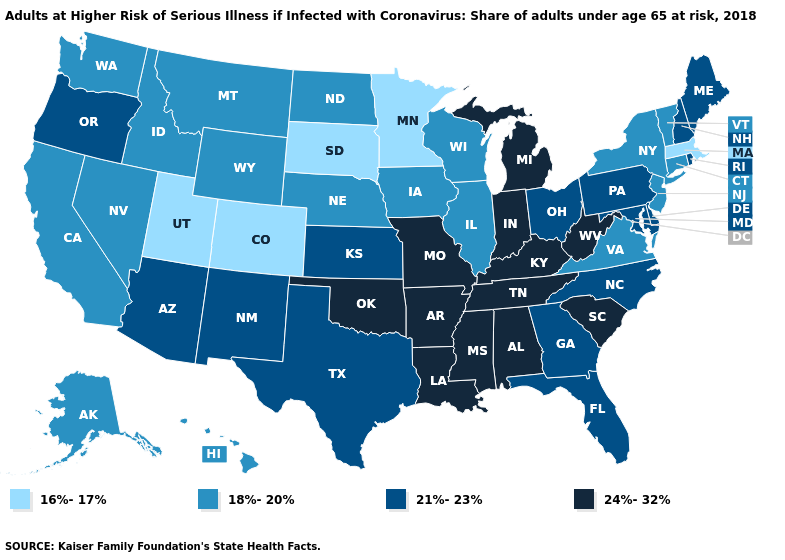Name the states that have a value in the range 24%-32%?
Be succinct. Alabama, Arkansas, Indiana, Kentucky, Louisiana, Michigan, Mississippi, Missouri, Oklahoma, South Carolina, Tennessee, West Virginia. What is the lowest value in states that border Connecticut?
Write a very short answer. 16%-17%. What is the lowest value in the USA?
Concise answer only. 16%-17%. Name the states that have a value in the range 24%-32%?
Quick response, please. Alabama, Arkansas, Indiana, Kentucky, Louisiana, Michigan, Mississippi, Missouri, Oklahoma, South Carolina, Tennessee, West Virginia. What is the value of Wyoming?
Concise answer only. 18%-20%. What is the lowest value in the USA?
Be succinct. 16%-17%. What is the value of Illinois?
Short answer required. 18%-20%. Name the states that have a value in the range 21%-23%?
Write a very short answer. Arizona, Delaware, Florida, Georgia, Kansas, Maine, Maryland, New Hampshire, New Mexico, North Carolina, Ohio, Oregon, Pennsylvania, Rhode Island, Texas. What is the highest value in the USA?
Keep it brief. 24%-32%. Among the states that border Texas , which have the lowest value?
Quick response, please. New Mexico. Name the states that have a value in the range 18%-20%?
Write a very short answer. Alaska, California, Connecticut, Hawaii, Idaho, Illinois, Iowa, Montana, Nebraska, Nevada, New Jersey, New York, North Dakota, Vermont, Virginia, Washington, Wisconsin, Wyoming. What is the value of Texas?
Write a very short answer. 21%-23%. Does Massachusetts have the lowest value in the Northeast?
Be succinct. Yes. Name the states that have a value in the range 18%-20%?
Short answer required. Alaska, California, Connecticut, Hawaii, Idaho, Illinois, Iowa, Montana, Nebraska, Nevada, New Jersey, New York, North Dakota, Vermont, Virginia, Washington, Wisconsin, Wyoming. What is the value of Iowa?
Quick response, please. 18%-20%. 